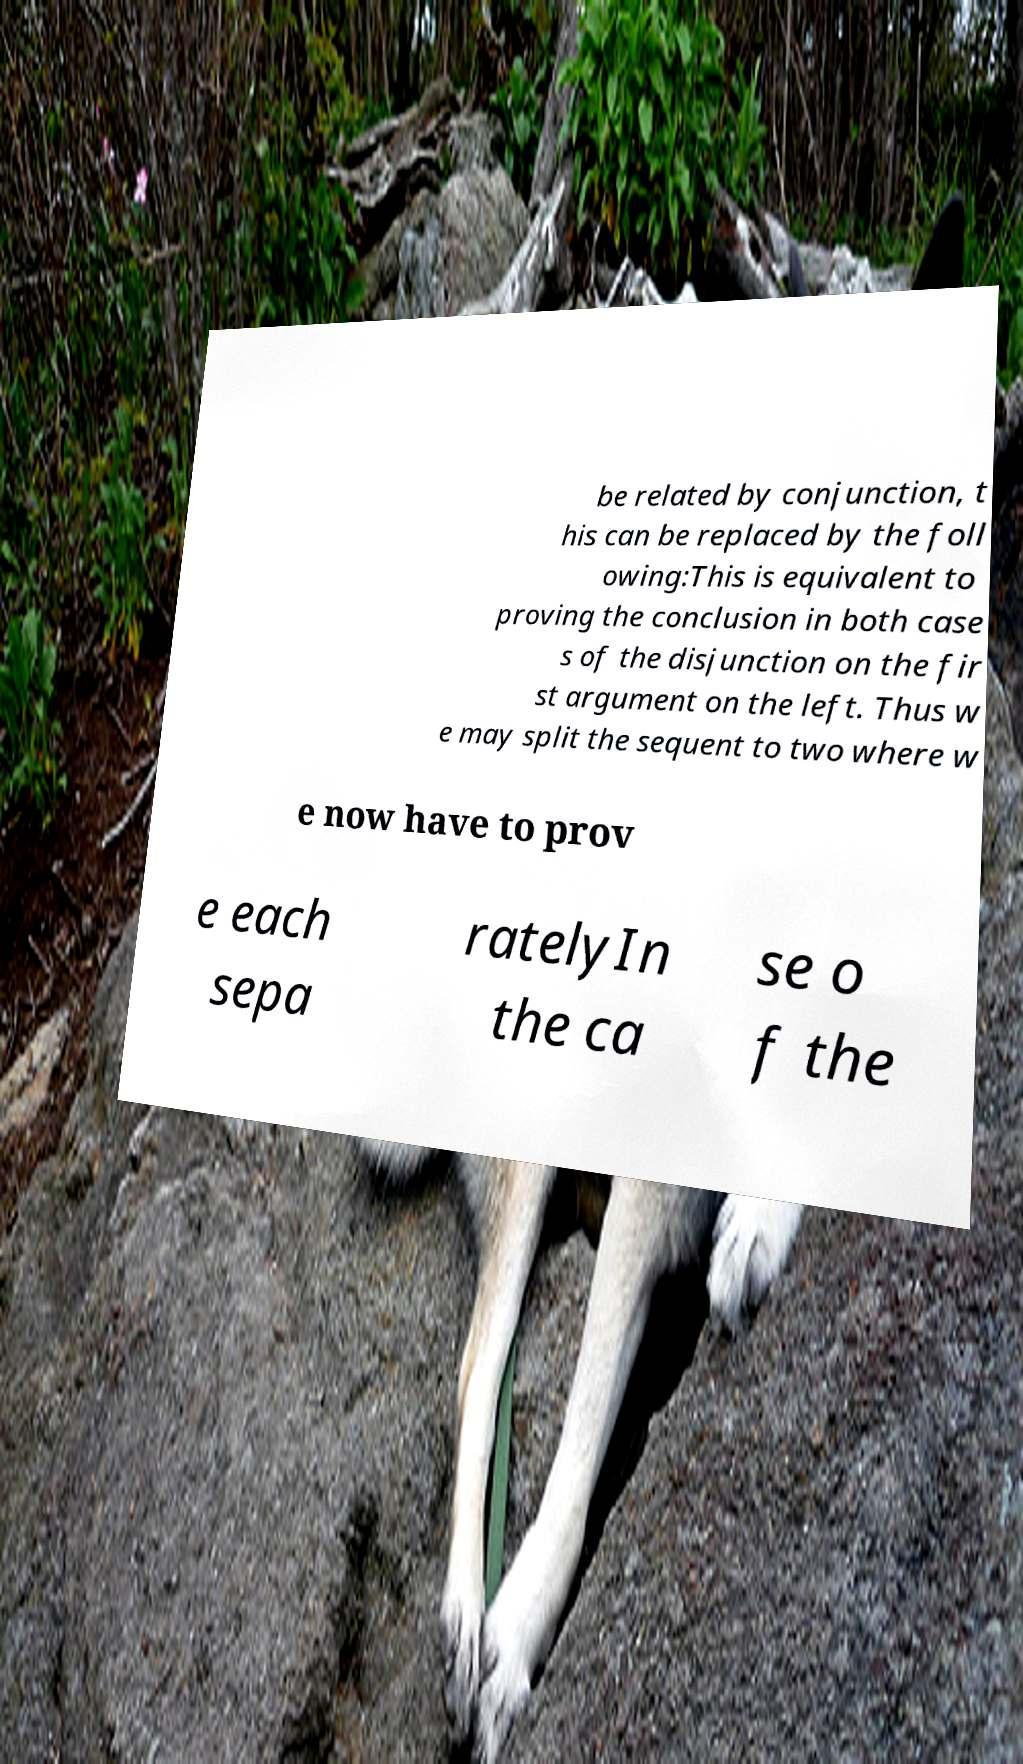There's text embedded in this image that I need extracted. Can you transcribe it verbatim? be related by conjunction, t his can be replaced by the foll owing:This is equivalent to proving the conclusion in both case s of the disjunction on the fir st argument on the left. Thus w e may split the sequent to two where w e now have to prov e each sepa ratelyIn the ca se o f the 